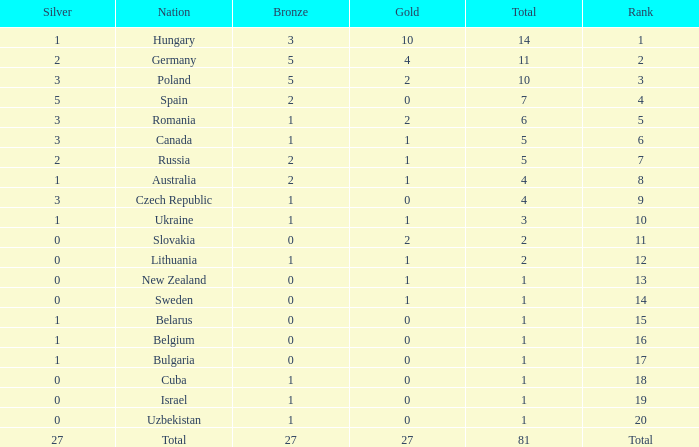Which Bronze has a Gold of 2, and a Nation of slovakia, and a Total larger than 2? None. 